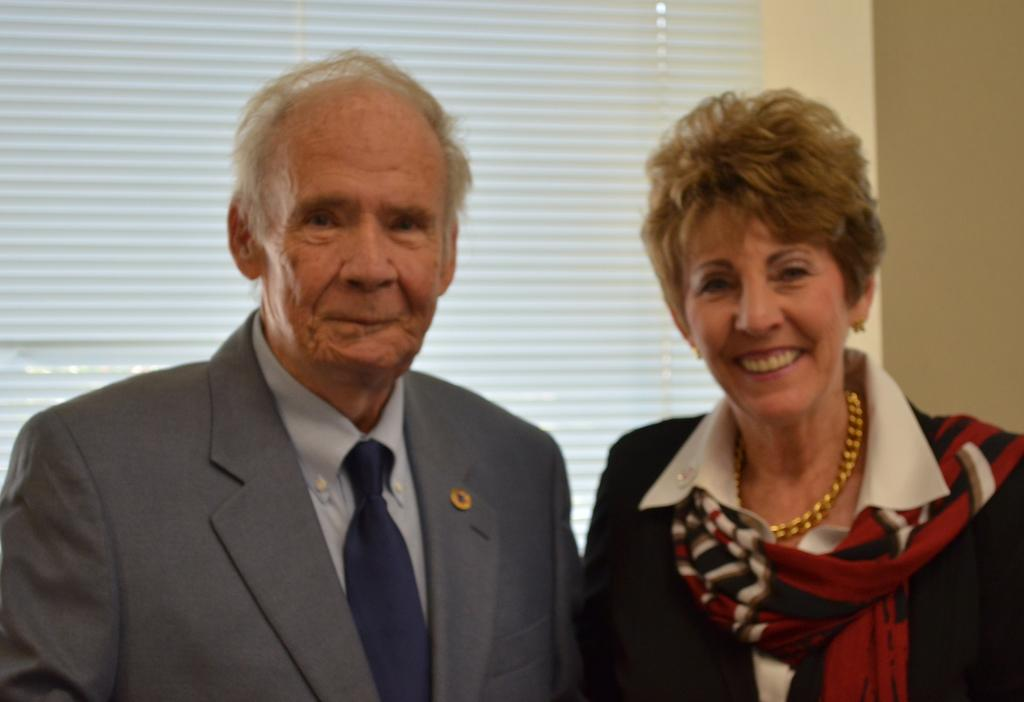What can be seen in the image? There are people standing in the image. Can you describe any specific features of the window in the image? There is a window with a blind in the image. How many toads can be seen on the window sill in the image? There are no toads present in the image. What type of bread is being served to the people in the image? There is no bread visible in the image. 